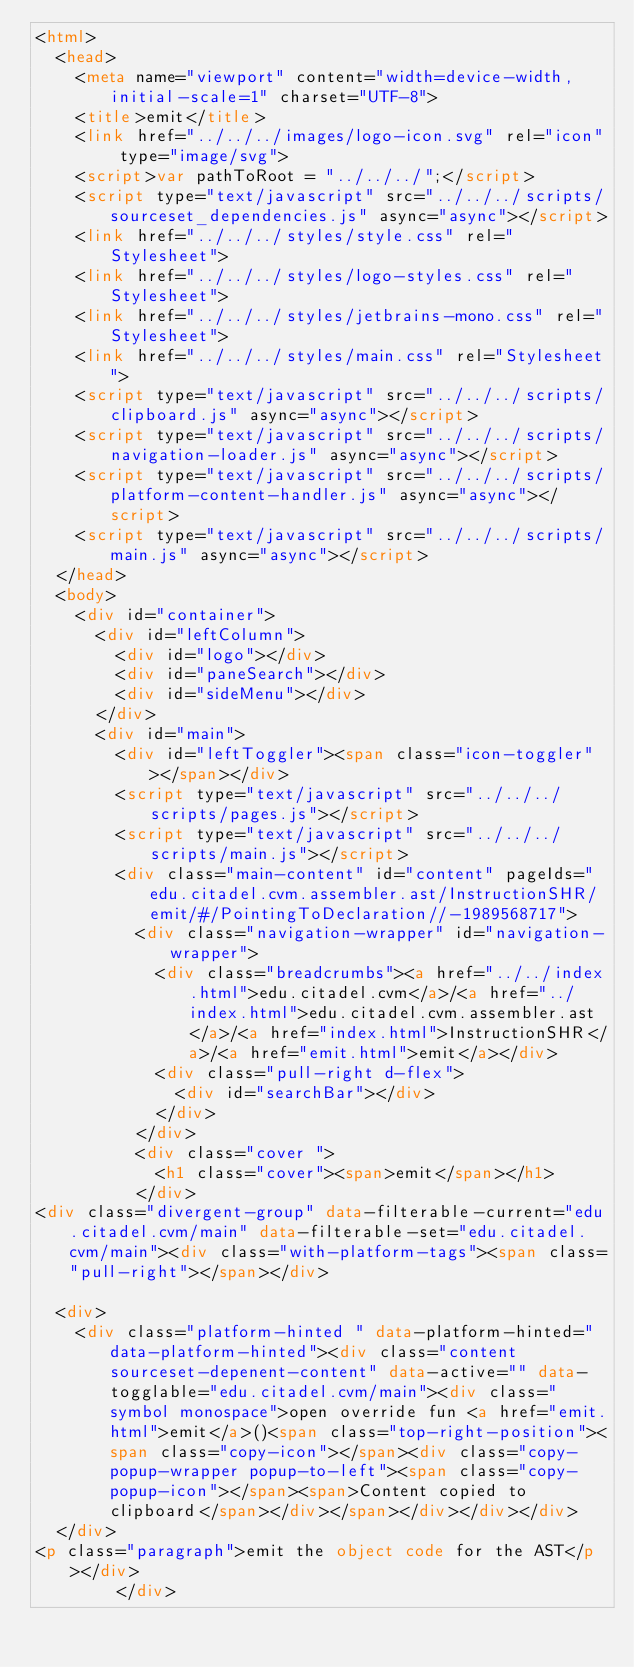Convert code to text. <code><loc_0><loc_0><loc_500><loc_500><_HTML_><html>
  <head>
    <meta name="viewport" content="width=device-width, initial-scale=1" charset="UTF-8">
    <title>emit</title>
    <link href="../../../images/logo-icon.svg" rel="icon" type="image/svg">
    <script>var pathToRoot = "../../../";</script>
    <script type="text/javascript" src="../../../scripts/sourceset_dependencies.js" async="async"></script>
    <link href="../../../styles/style.css" rel="Stylesheet">
    <link href="../../../styles/logo-styles.css" rel="Stylesheet">
    <link href="../../../styles/jetbrains-mono.css" rel="Stylesheet">
    <link href="../../../styles/main.css" rel="Stylesheet">
    <script type="text/javascript" src="../../../scripts/clipboard.js" async="async"></script>
    <script type="text/javascript" src="../../../scripts/navigation-loader.js" async="async"></script>
    <script type="text/javascript" src="../../../scripts/platform-content-handler.js" async="async"></script>
    <script type="text/javascript" src="../../../scripts/main.js" async="async"></script>
  </head>
  <body>
    <div id="container">
      <div id="leftColumn">
        <div id="logo"></div>
        <div id="paneSearch"></div>
        <div id="sideMenu"></div>
      </div>
      <div id="main">
        <div id="leftToggler"><span class="icon-toggler"></span></div>
        <script type="text/javascript" src="../../../scripts/pages.js"></script>
        <script type="text/javascript" src="../../../scripts/main.js"></script>
        <div class="main-content" id="content" pageIds="edu.citadel.cvm.assembler.ast/InstructionSHR/emit/#/PointingToDeclaration//-1989568717">
          <div class="navigation-wrapper" id="navigation-wrapper">
            <div class="breadcrumbs"><a href="../../index.html">edu.citadel.cvm</a>/<a href="../index.html">edu.citadel.cvm.assembler.ast</a>/<a href="index.html">InstructionSHR</a>/<a href="emit.html">emit</a></div>
            <div class="pull-right d-flex">
              <div id="searchBar"></div>
            </div>
          </div>
          <div class="cover ">
            <h1 class="cover"><span>emit</span></h1>
          </div>
<div class="divergent-group" data-filterable-current="edu.citadel.cvm/main" data-filterable-set="edu.citadel.cvm/main"><div class="with-platform-tags"><span class="pull-right"></span></div>

  <div>
    <div class="platform-hinted " data-platform-hinted="data-platform-hinted"><div class="content sourceset-depenent-content" data-active="" data-togglable="edu.citadel.cvm/main"><div class="symbol monospace">open override fun <a href="emit.html">emit</a>()<span class="top-right-position"><span class="copy-icon"></span><div class="copy-popup-wrapper popup-to-left"><span class="copy-popup-icon"></span><span>Content copied to clipboard</span></div></span></div></div></div>
  </div>
<p class="paragraph">emit the object code for the AST</p></div>
        </div></code> 